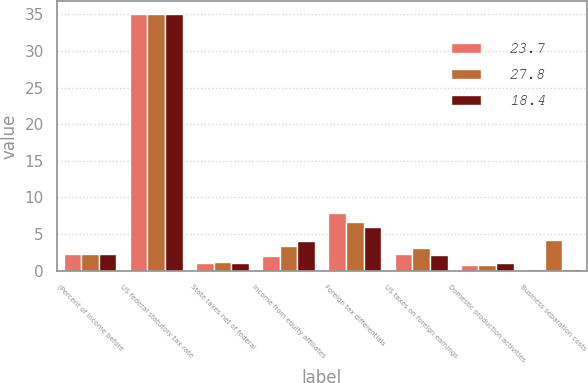<chart> <loc_0><loc_0><loc_500><loc_500><stacked_bar_chart><ecel><fcel>(Percent of income before<fcel>US federal statutory tax rate<fcel>State taxes net of federal<fcel>Income from equity affiliates<fcel>Foreign tax differentials<fcel>US taxes on foreign earnings<fcel>Domestic production activities<fcel>Business separation costs<nl><fcel>23.7<fcel>2.2<fcel>35<fcel>1<fcel>2<fcel>7.9<fcel>2.2<fcel>0.8<fcel>0.2<nl><fcel>27.8<fcel>2.2<fcel>35<fcel>1.2<fcel>3.3<fcel>6.6<fcel>3.1<fcel>0.8<fcel>4.2<nl><fcel>18.4<fcel>2.2<fcel>35<fcel>1.1<fcel>4<fcel>5.9<fcel>2.1<fcel>1<fcel>0.2<nl></chart> 